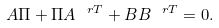<formula> <loc_0><loc_0><loc_500><loc_500>A \Pi + \Pi A ^ { \ r T } + B B ^ { \ r T } = 0 .</formula> 